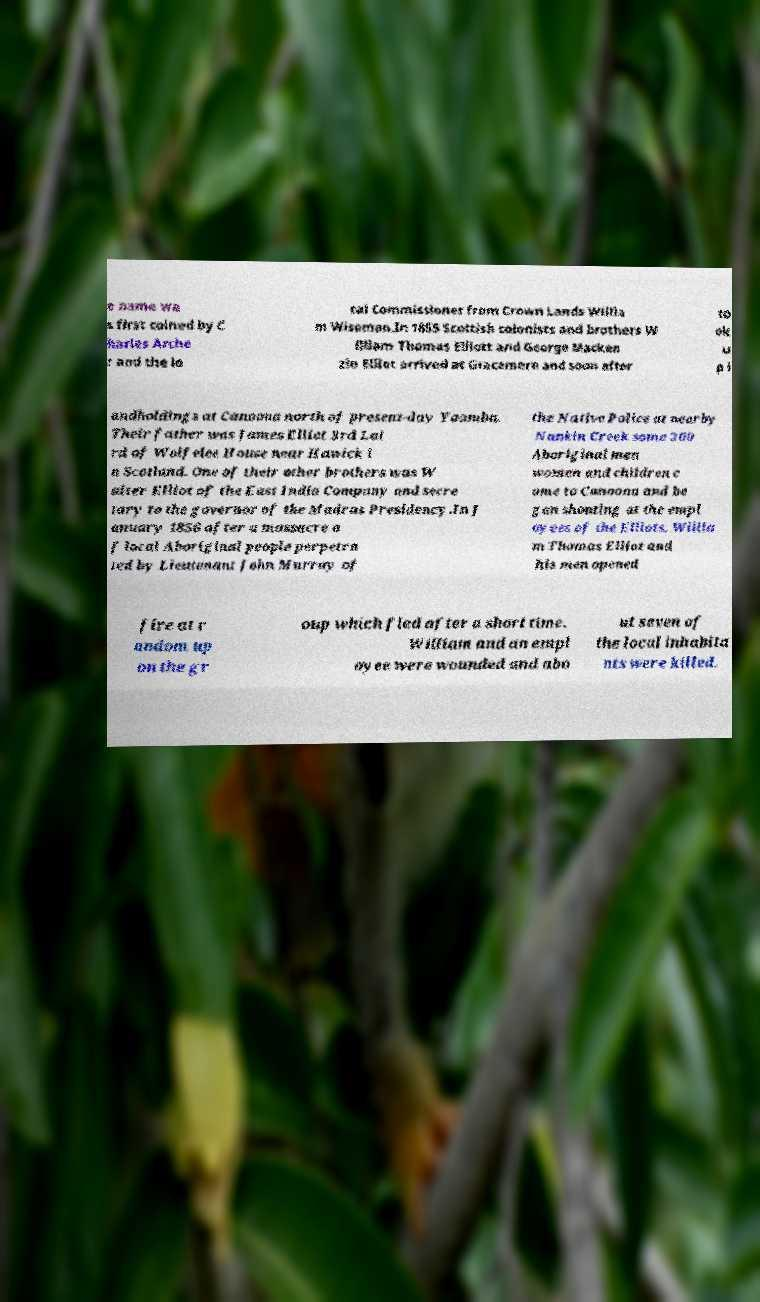Can you read and provide the text displayed in the image?This photo seems to have some interesting text. Can you extract and type it out for me? e name wa s first coined by C harles Arche r and the lo cal Commissioner from Crown Lands Willia m Wiseman.In 1855 Scottish colonists and brothers W illiam Thomas Elliott and George Macken zie Elliot arrived at Gracemere and soon after to ok u p l andholdings at Canoona north of present-day Yaamba. Their father was James Elliot 3rd Lai rd of Wolfelee House near Hawick i n Scotland. One of their other brothers was W alter Elliot of the East India Company and secre tary to the governor of the Madras Presidency.In J anuary 1856 after a massacre o f local Aboriginal people perpetra ted by Lieutenant John Murray of the Native Police at nearby Nankin Creek some 200 Aboriginal men women and children c ame to Canoona and be gan shouting at the empl oyees of the Elliots. Willia m Thomas Elliot and his men opened fire at r andom up on the gr oup which fled after a short time. William and an empl oyee were wounded and abo ut seven of the local inhabita nts were killed. 